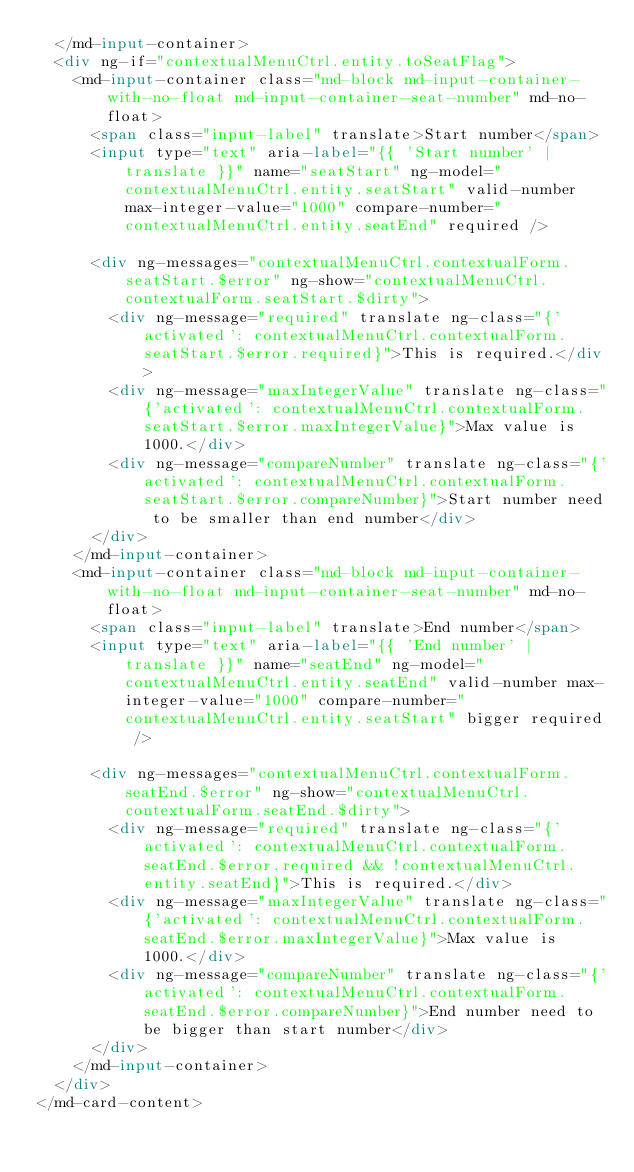<code> <loc_0><loc_0><loc_500><loc_500><_HTML_>  </md-input-container>
  <div ng-if="contextualMenuCtrl.entity.toSeatFlag">
    <md-input-container class="md-block md-input-container-with-no-float md-input-container-seat-number" md-no-float>
      <span class="input-label" translate>Start number</span>
      <input type="text" aria-label="{{ 'Start number' | translate }}" name="seatStart" ng-model="contextualMenuCtrl.entity.seatStart" valid-number max-integer-value="1000" compare-number="contextualMenuCtrl.entity.seatEnd" required />

      <div ng-messages="contextualMenuCtrl.contextualForm.seatStart.$error" ng-show="contextualMenuCtrl.contextualForm.seatStart.$dirty">
        <div ng-message="required" translate ng-class="{'activated': contextualMenuCtrl.contextualForm.seatStart.$error.required}">This is required.</div>
        <div ng-message="maxIntegerValue" translate ng-class="{'activated': contextualMenuCtrl.contextualForm.seatStart.$error.maxIntegerValue}">Max value is 1000.</div>
        <div ng-message="compareNumber" translate ng-class="{'activated': contextualMenuCtrl.contextualForm.seatStart.$error.compareNumber}">Start number need to be smaller than end number</div>
      </div>
    </md-input-container>
    <md-input-container class="md-block md-input-container-with-no-float md-input-container-seat-number" md-no-float>
      <span class="input-label" translate>End number</span>
      <input type="text" aria-label="{{ 'End number' | translate }}" name="seatEnd" ng-model="contextualMenuCtrl.entity.seatEnd" valid-number max-integer-value="1000" compare-number="contextualMenuCtrl.entity.seatStart" bigger required />

      <div ng-messages="contextualMenuCtrl.contextualForm.seatEnd.$error" ng-show="contextualMenuCtrl.contextualForm.seatEnd.$dirty">
        <div ng-message="required" translate ng-class="{'activated': contextualMenuCtrl.contextualForm.seatEnd.$error.required && !contextualMenuCtrl.entity.seatEnd}">This is required.</div>
        <div ng-message="maxIntegerValue" translate ng-class="{'activated': contextualMenuCtrl.contextualForm.seatEnd.$error.maxIntegerValue}">Max value is 1000.</div>
        <div ng-message="compareNumber" translate ng-class="{'activated': contextualMenuCtrl.contextualForm.seatEnd.$error.compareNumber}">End number need to be bigger than start number</div>
      </div>
    </md-input-container>
  </div>
</md-card-content>
</code> 